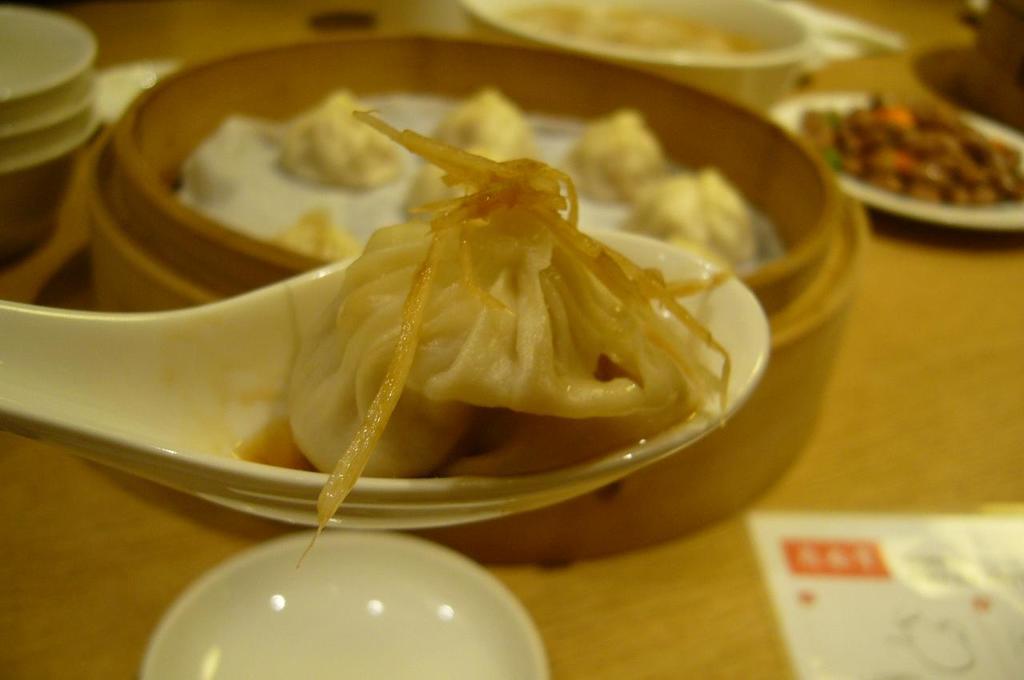Please provide a concise description of this image. In this image we can see few bowls with food item and a paper on the table and there is a food item on the spoon. 